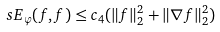Convert formula to latex. <formula><loc_0><loc_0><loc_500><loc_500>\ s E _ { \varphi } ( f , f ) \leq c _ { 4 } ( \| f \| ^ { 2 } _ { 2 } + \| \nabla f \| _ { 2 } ^ { 2 } )</formula> 